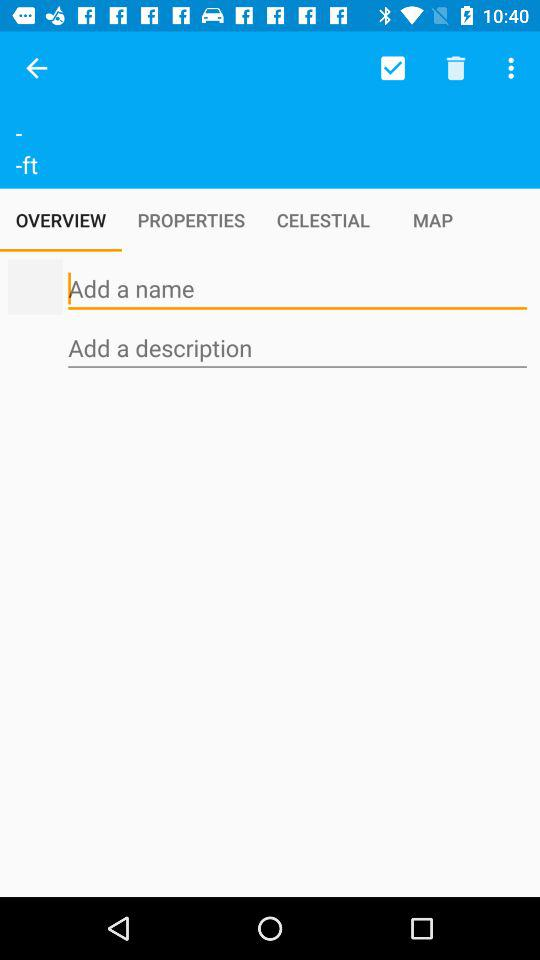Which tab is selected? The selected tab is "OVERVIEW". 